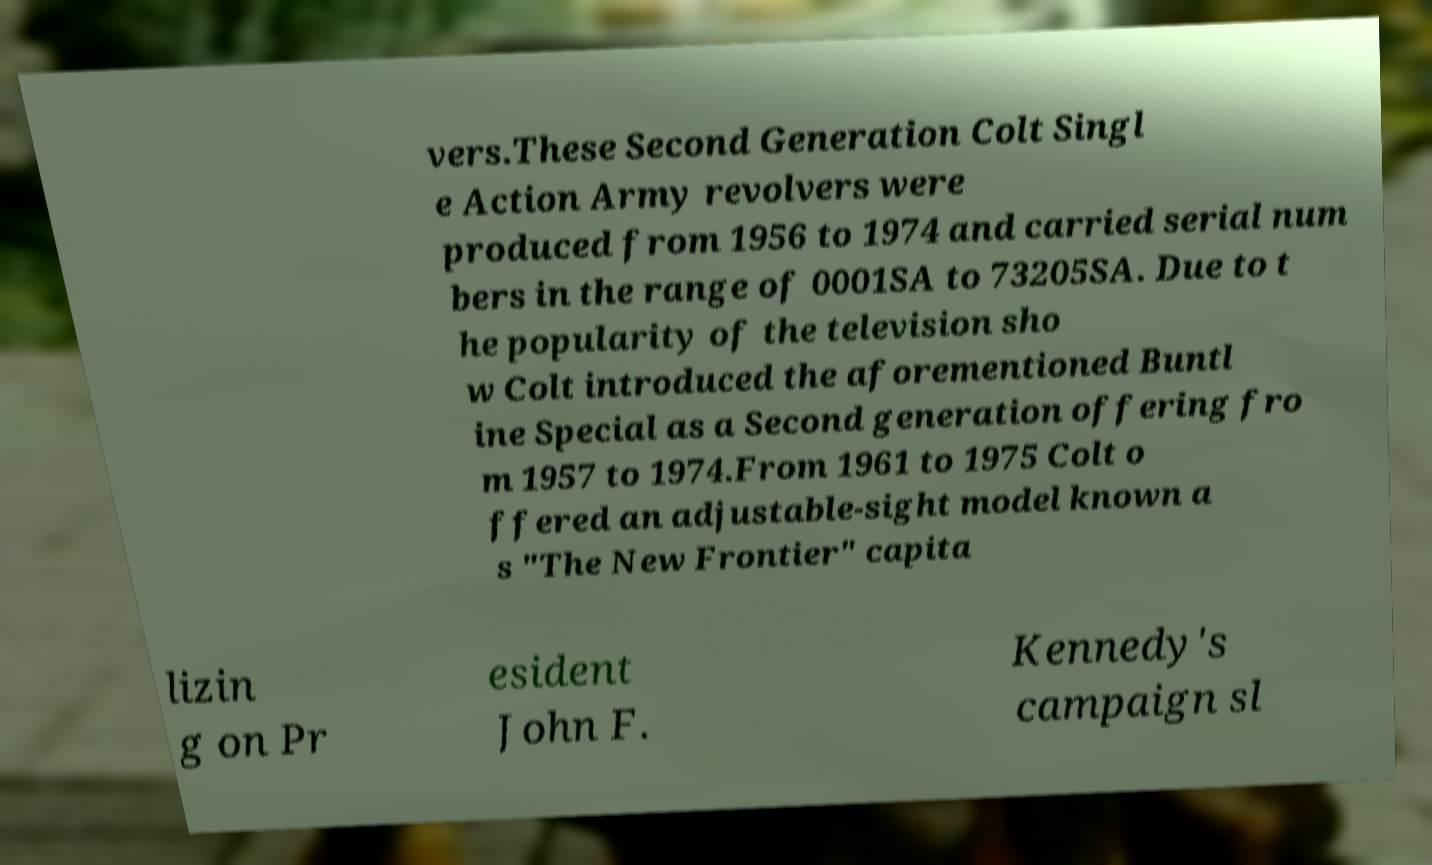What messages or text are displayed in this image? I need them in a readable, typed format. vers.These Second Generation Colt Singl e Action Army revolvers were produced from 1956 to 1974 and carried serial num bers in the range of 0001SA to 73205SA. Due to t he popularity of the television sho w Colt introduced the aforementioned Buntl ine Special as a Second generation offering fro m 1957 to 1974.From 1961 to 1975 Colt o ffered an adjustable-sight model known a s "The New Frontier" capita lizin g on Pr esident John F. Kennedy's campaign sl 